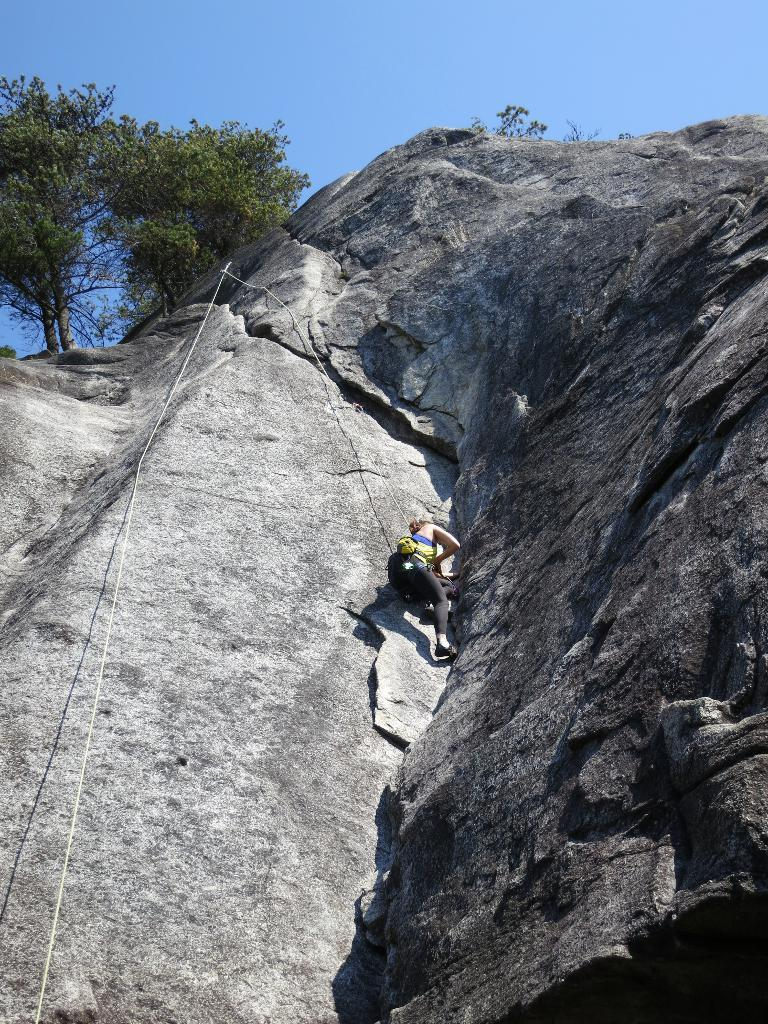Who is the main subject in the image? There is a woman in the image. What is the woman doing in the image? The woman is climbing a hill. What tool is the woman using to assist her in climbing the hill? The woman is using a rope. What can be seen at the top of the hill? There are trees on the top of the hill. What type of wish can be granted by the trees at the top of the hill? There is no mention of wishes or magical trees in the image; the trees are simply a part of the hill's landscape. 